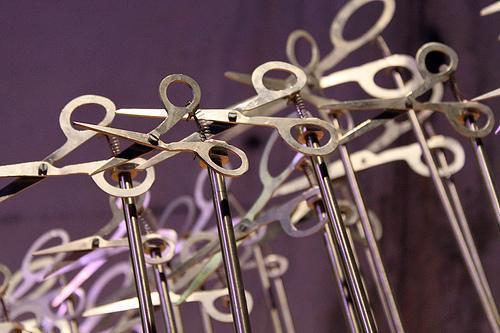How many scissors are there?
Give a very brief answer. 11. 